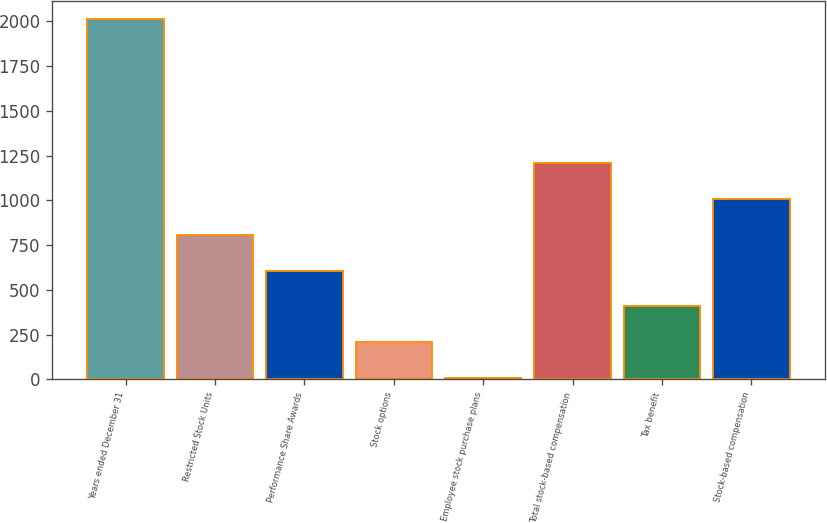Convert chart. <chart><loc_0><loc_0><loc_500><loc_500><bar_chart><fcel>Years ended December 31<fcel>Restricted Stock Units<fcel>Performance Share Awards<fcel>Stock options<fcel>Employee stock purchase plans<fcel>Total stock-based compensation<fcel>Tax benefit<fcel>Stock-based compensation<nl><fcel>2011<fcel>808<fcel>607.5<fcel>206.5<fcel>6<fcel>1209<fcel>407<fcel>1008.5<nl></chart> 